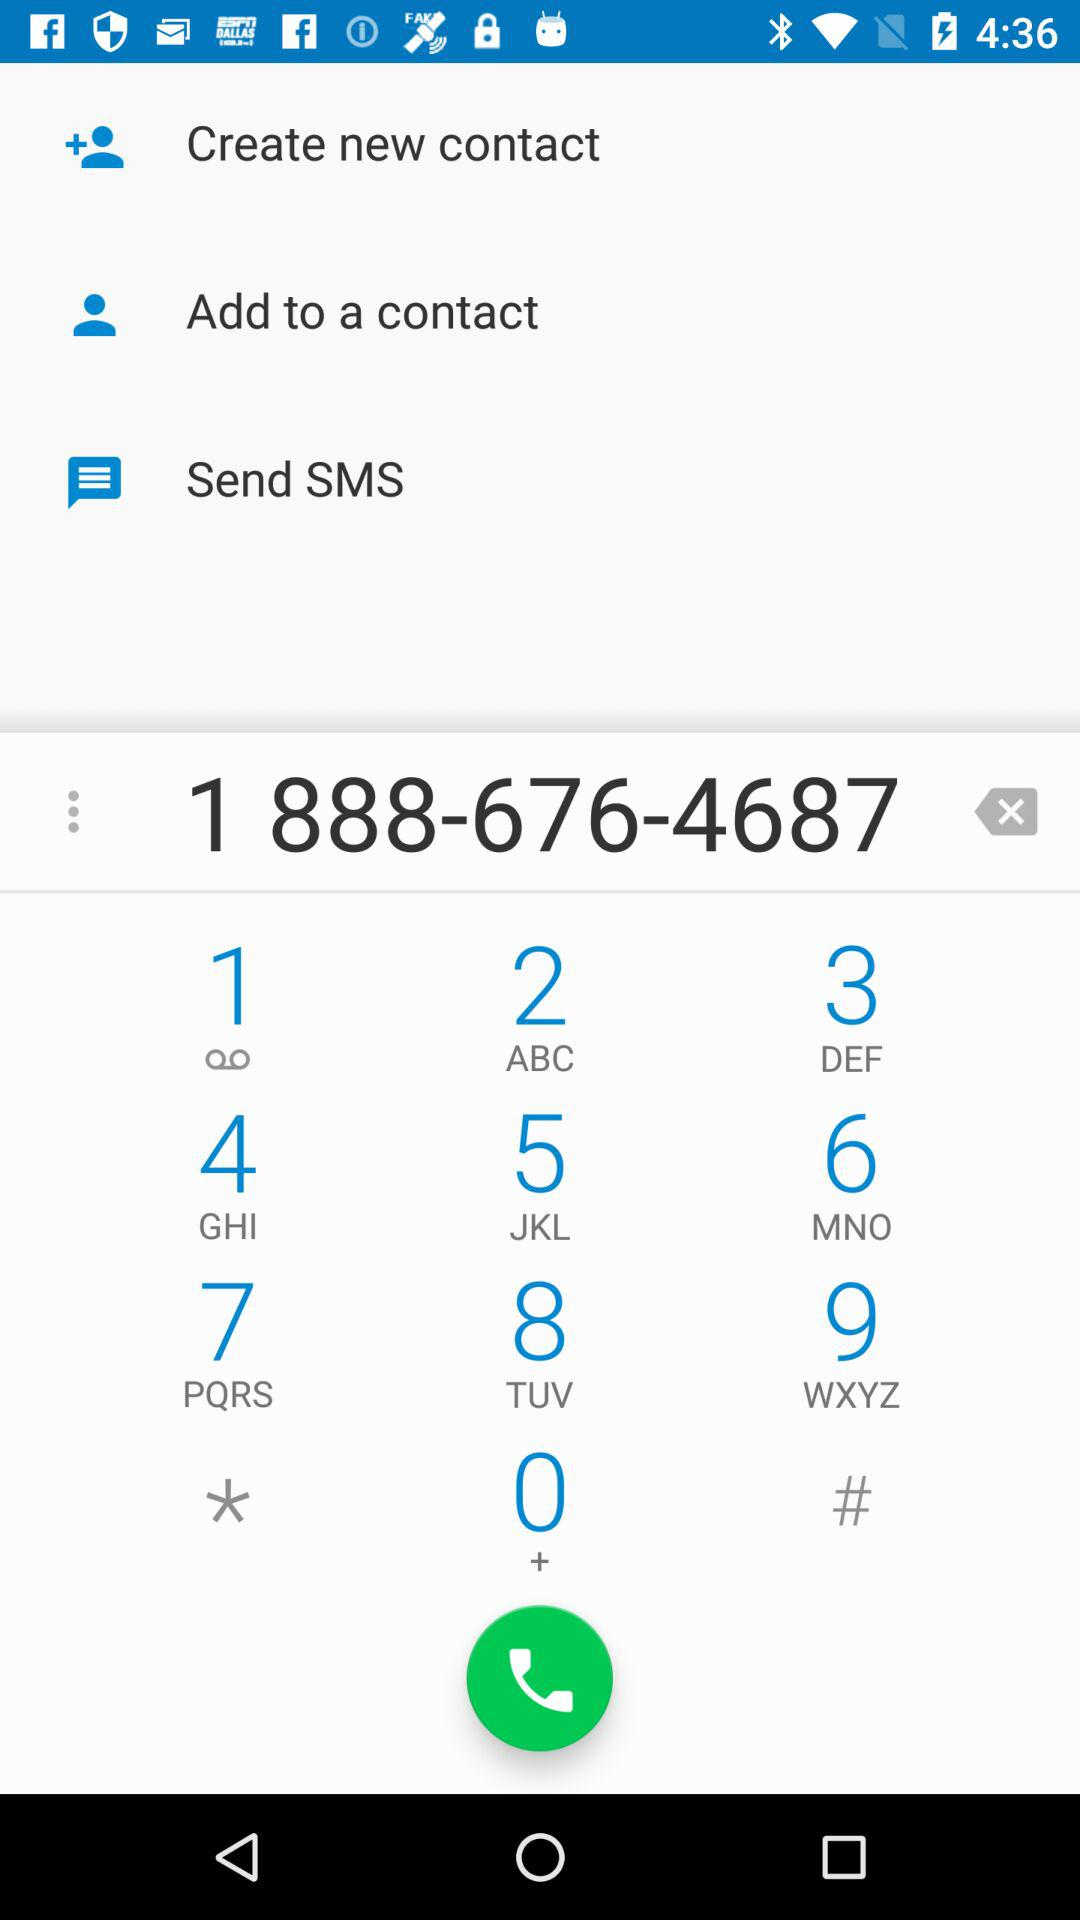What is the number on the screen? The number is 1 888-676-4687. 